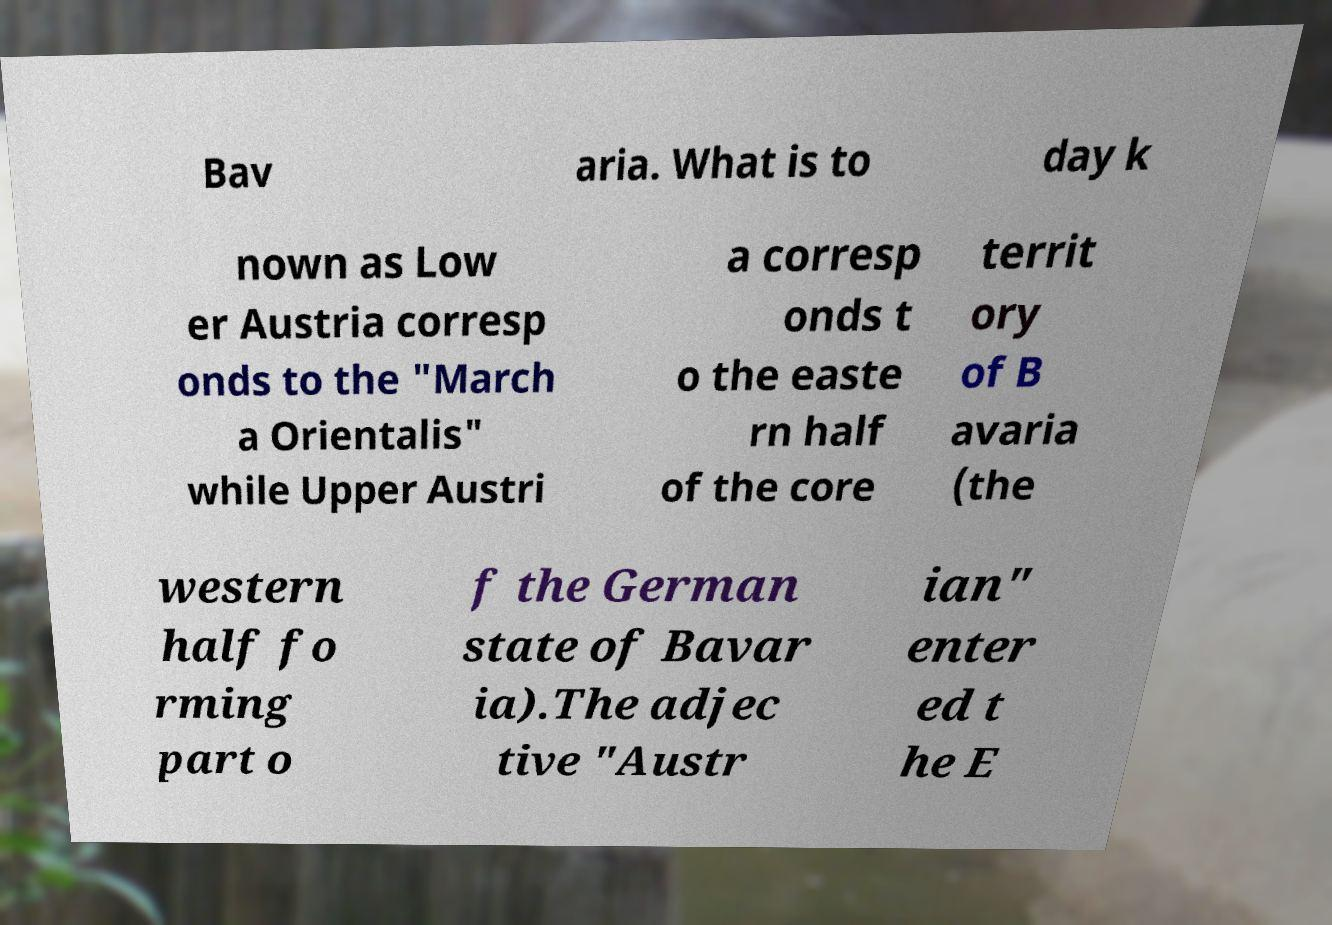What messages or text are displayed in this image? I need them in a readable, typed format. Bav aria. What is to day k nown as Low er Austria corresp onds to the "March a Orientalis" while Upper Austri a corresp onds t o the easte rn half of the core territ ory of B avaria (the western half fo rming part o f the German state of Bavar ia).The adjec tive "Austr ian" enter ed t he E 